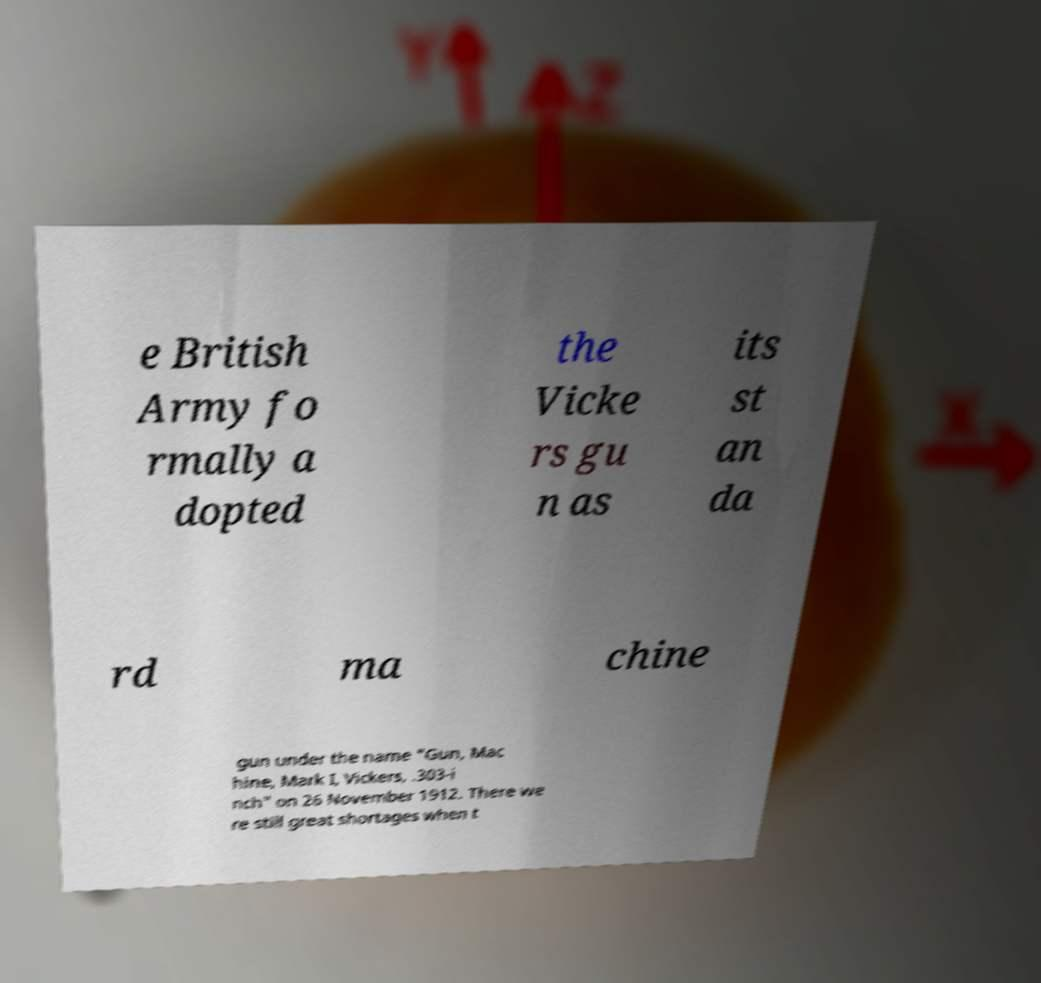For documentation purposes, I need the text within this image transcribed. Could you provide that? e British Army fo rmally a dopted the Vicke rs gu n as its st an da rd ma chine gun under the name "Gun, Mac hine, Mark I, Vickers, .303-i nch" on 26 November 1912. There we re still great shortages when t 